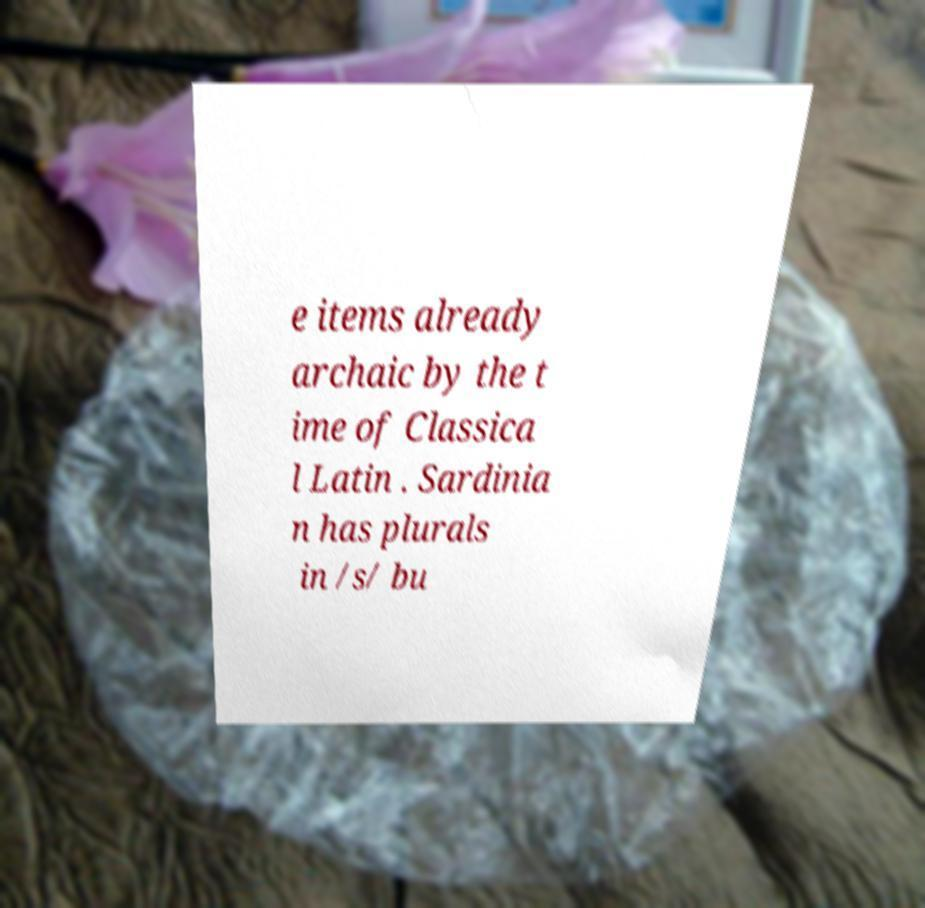Could you assist in decoding the text presented in this image and type it out clearly? e items already archaic by the t ime of Classica l Latin . Sardinia n has plurals in /s/ bu 